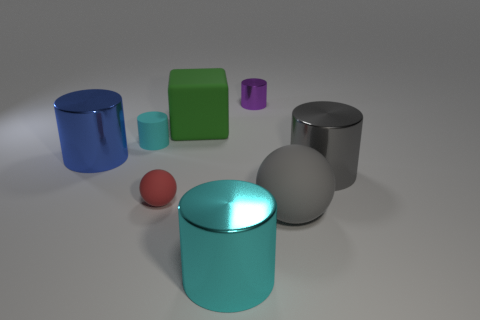Is the material of the cyan thing that is left of the matte block the same as the red ball?
Keep it short and to the point. Yes. What is the shape of the large object that is both in front of the rubber cube and left of the large cyan metallic cylinder?
Give a very brief answer. Cylinder. Are there any matte objects that are right of the shiny cylinder that is behind the large blue shiny cylinder?
Your answer should be compact. Yes. There is a tiny object in front of the large blue object; is it the same shape as the big shiny thing on the right side of the purple shiny object?
Give a very brief answer. No. Does the big blue thing have the same material as the tiny red sphere?
Give a very brief answer. No. How big is the shiny cylinder that is to the left of the large green matte block on the left side of the large metal cylinder that is to the right of the purple cylinder?
Offer a terse response. Large. What number of other things are there of the same color as the small rubber cylinder?
Keep it short and to the point. 1. There is a gray rubber thing that is the same size as the blue metallic cylinder; what shape is it?
Ensure brevity in your answer.  Sphere. What number of large things are blue shiny things or green matte blocks?
Make the answer very short. 2. There is a large metallic thing behind the gray cylinder in front of the small purple metallic cylinder; is there a cyan cylinder that is behind it?
Provide a short and direct response. Yes. 